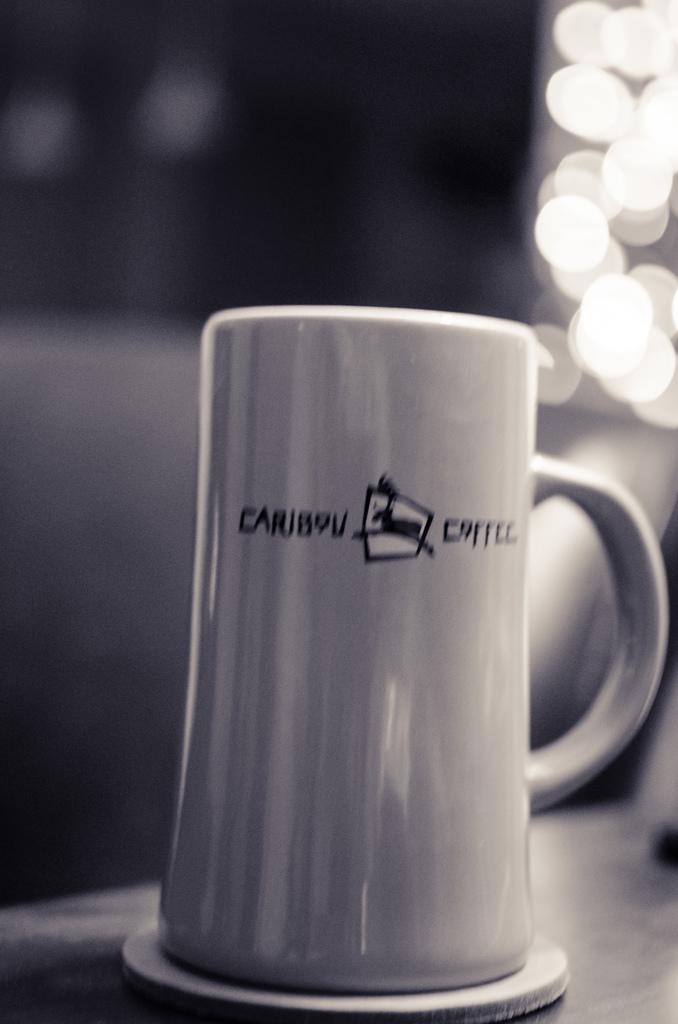<image>
Summarize the visual content of the image. A Caribou Coffee cup in a black and white photo. 